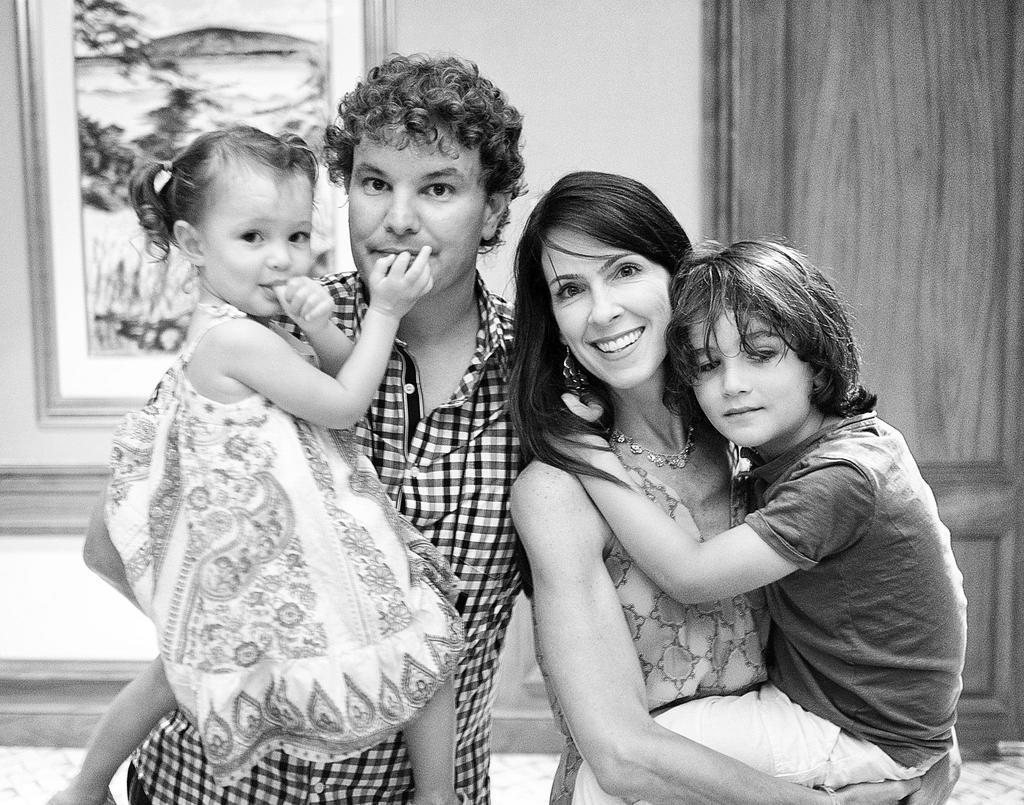Can you describe this image briefly? A man is standing by holding a girl in his hand, he wore a shirt beside him a beautiful woman is standing by holding a boy in her hands. Behind them there is a wall. 